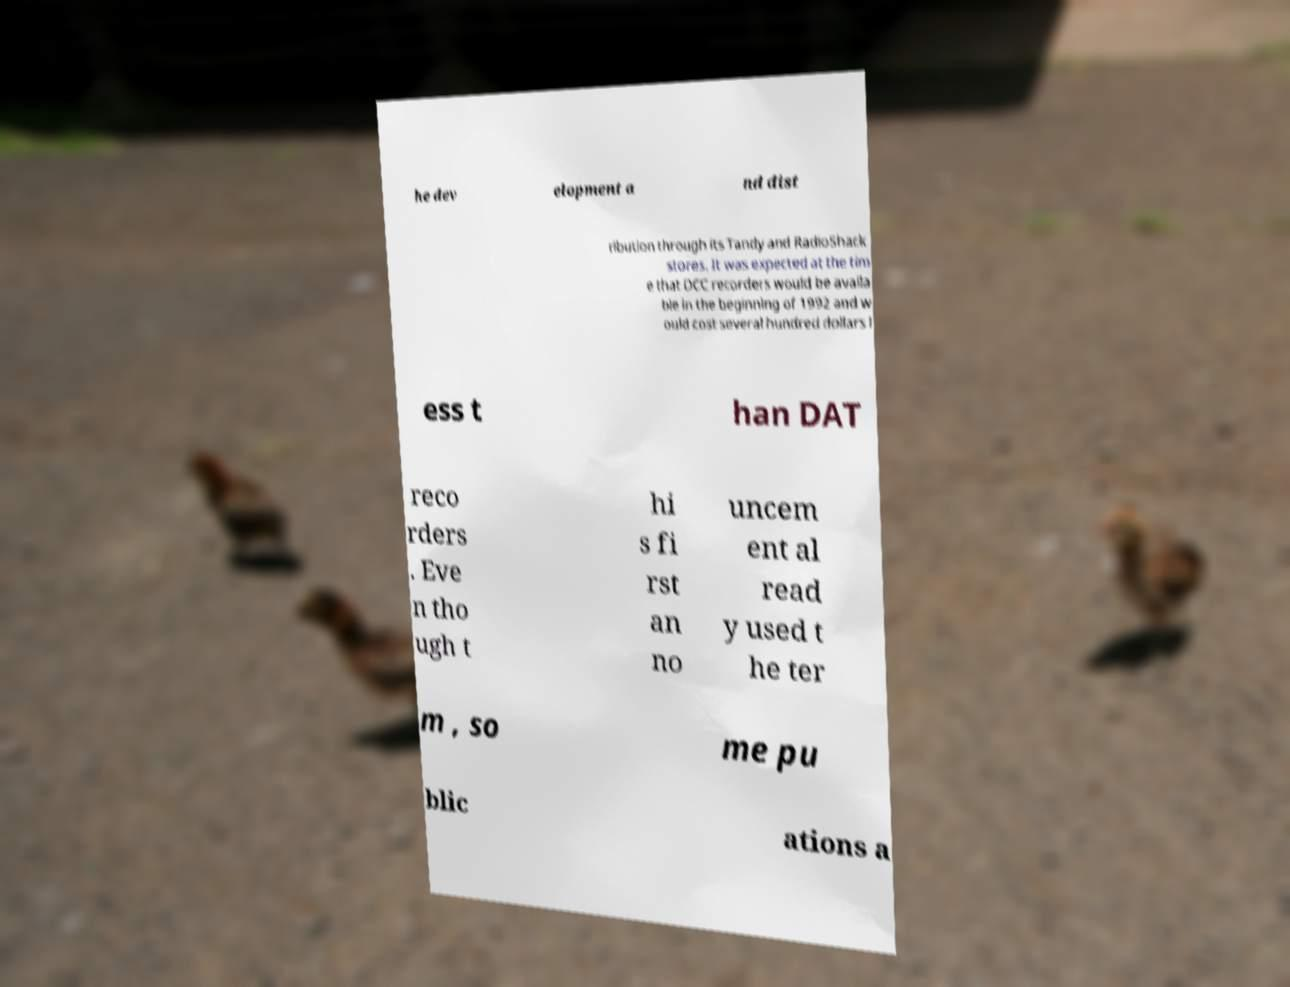There's text embedded in this image that I need extracted. Can you transcribe it verbatim? he dev elopment a nd dist ribution through its Tandy and RadioShack stores. It was expected at the tim e that DCC recorders would be availa ble in the beginning of 1992 and w ould cost several hundred dollars l ess t han DAT reco rders . Eve n tho ugh t hi s fi rst an no uncem ent al read y used t he ter m , so me pu blic ations a 